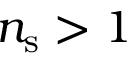<formula> <loc_0><loc_0><loc_500><loc_500>n _ { s } > 1</formula> 